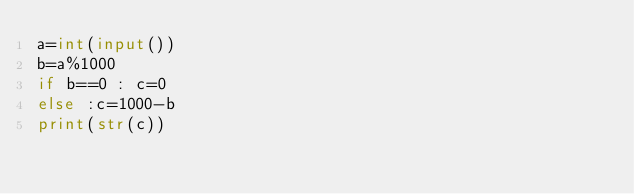<code> <loc_0><loc_0><loc_500><loc_500><_Python_>a=int(input())
b=a%1000
if b==0 : c=0
else :c=1000-b
print(str(c))</code> 